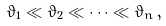Convert formula to latex. <formula><loc_0><loc_0><loc_500><loc_500>\vartheta _ { 1 } \ll \vartheta _ { 2 } \ll \cdots \ll \vartheta _ { n } \, ,</formula> 